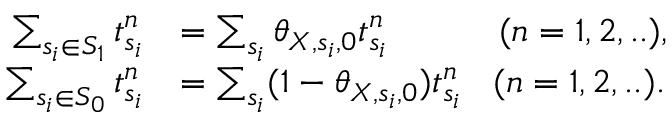Convert formula to latex. <formula><loc_0><loc_0><loc_500><loc_500>\begin{array} { r l } { \sum _ { s _ { i } \in S _ { 1 } } t _ { s _ { i } } ^ { n } } & { = \sum _ { s _ { i } } \theta _ { X , s _ { i } , 0 } t _ { s _ { i } } ^ { n } \, ( n = 1 , 2 , . . ) , } \\ { \sum _ { s _ { i } \in S _ { 0 } } t _ { s _ { i } } ^ { n } } & { = \sum _ { s _ { i } } ( 1 - \theta _ { X , s _ { i } , 0 } ) t _ { s _ { i } } ^ { n } \, ( n = 1 , 2 , . . ) . } \end{array}</formula> 